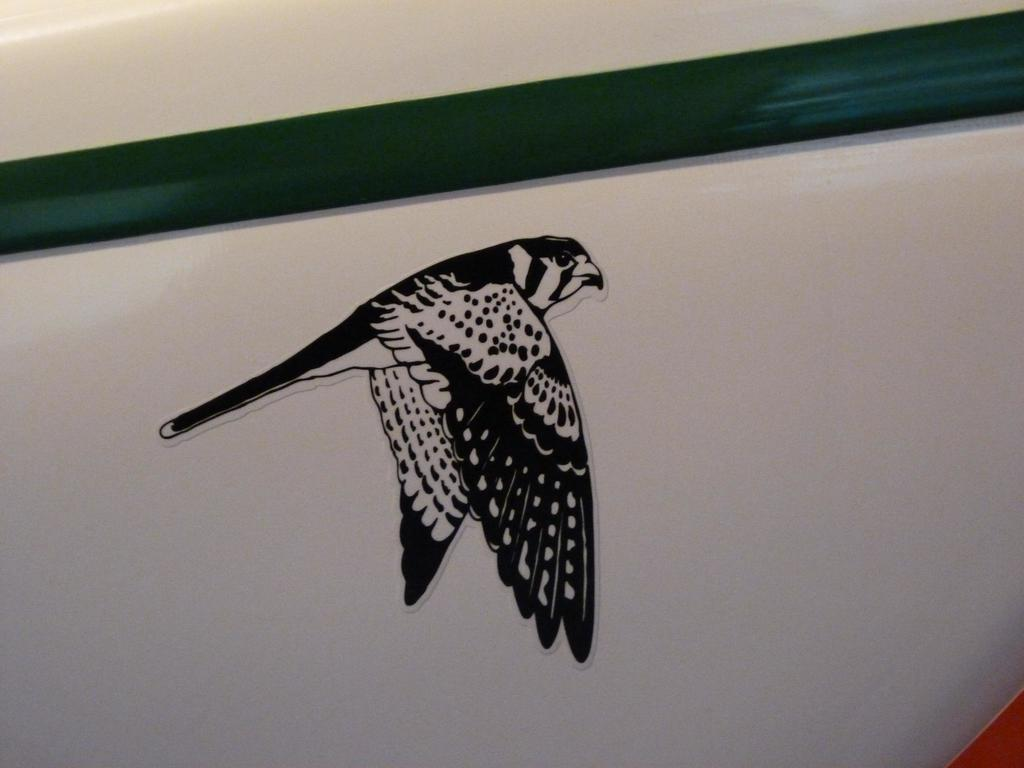What is on the wall in the image? There is a sticker of a bird on the wall in the image. What time is displayed on the hour on the wall in the image? There is no hour or clock present in the image; it only features a sticker of a bird on the wall. 